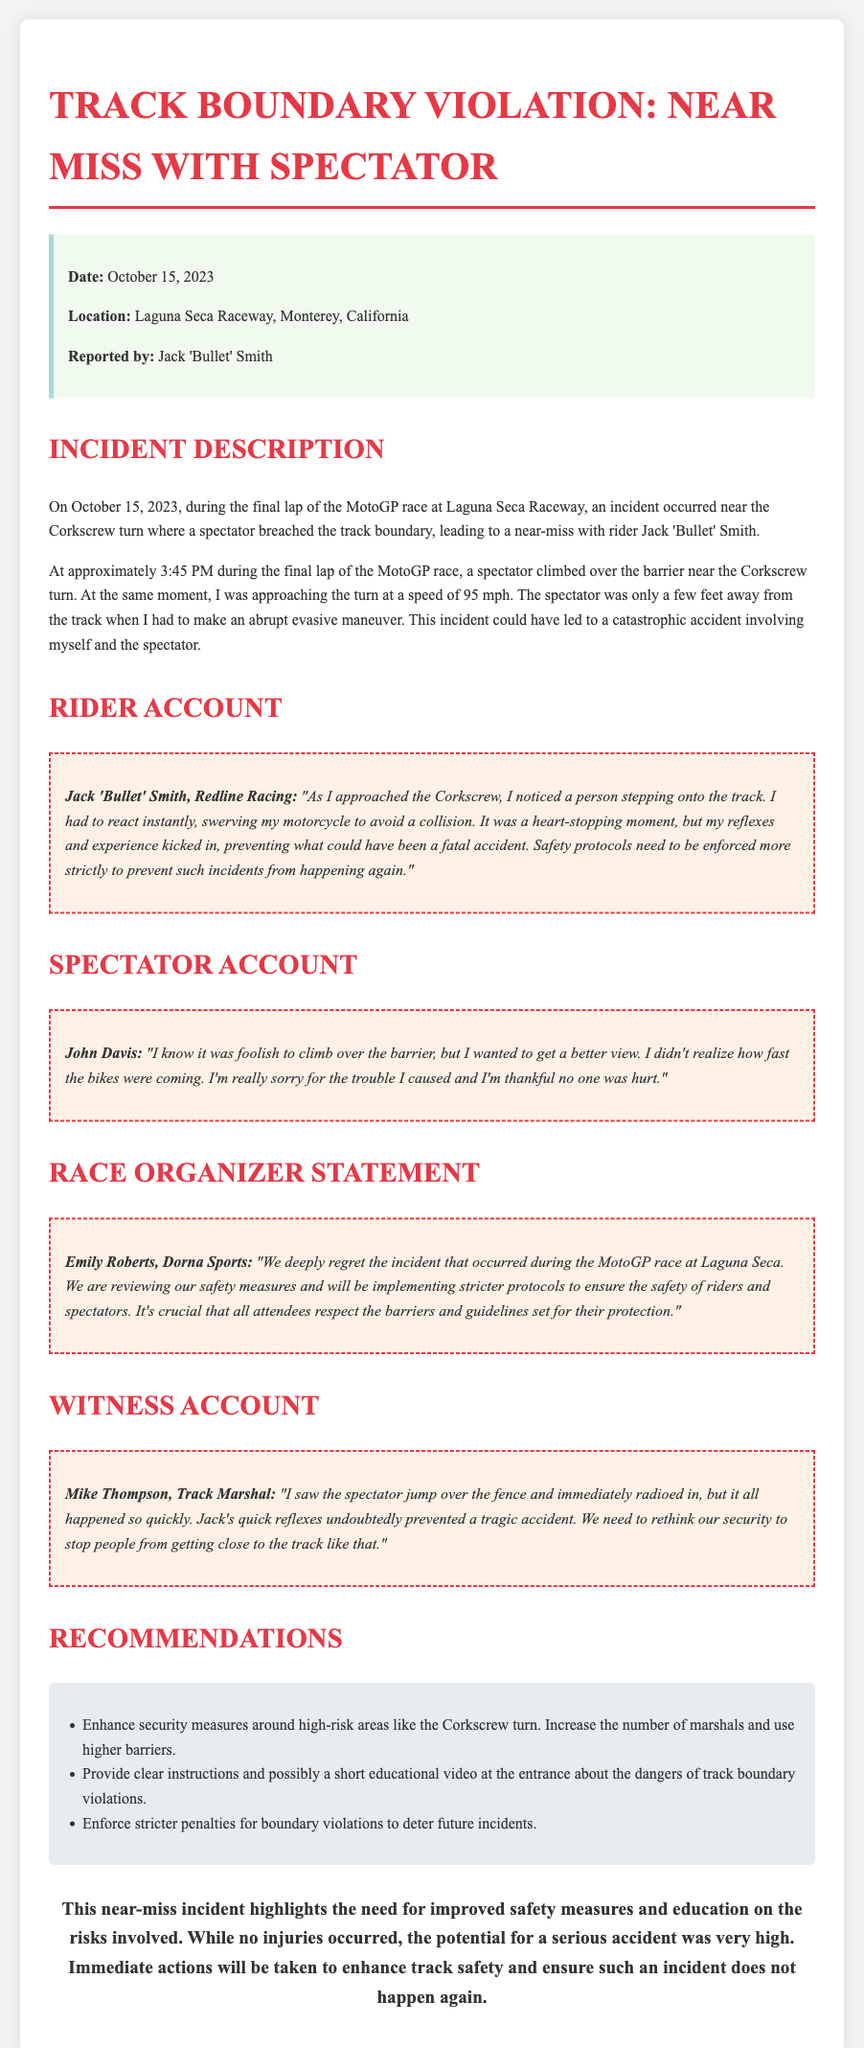what date did the incident occur? The date of the incident is mentioned in the info section.
Answer: October 15, 2023 who reported the incident? The report states who reported the incident in the info section.
Answer: Jack 'Bullet' Smith where did the incident take place? The location of the incident is specified in the info section.
Answer: Laguna Seca Raceway, Monterey, California what was the speed of the motorcycle during the near-miss? The speed at which the motorcycle was approaching is stated in the incident description.
Answer: 95 mph what safety measure is proposed regarding spectator barriers? Recommendations regarding barriers are mentioned in the recommendations section.
Answer: Increase the number of marshals and use higher barriers why did the spectator breach the track boundary? The spectator's reasoning for climbing over is detailed in his account.
Answer: Wanted to get a better view who was responsible for addressing safety measures following the incident? The race organizer responsible for addressing the issue is identified in the race organizer statement.
Answer: Emily Roberts, Dorna Sports what did the track marshal witness? The witness account from the track marshal describes specific actions.
Answer: The spectator jump over the fence what are the potential consequences mentioned for boundary violations? The recommendations outline consequences for boundary violations.
Answer: Enforce stricter penalties for boundary violations 